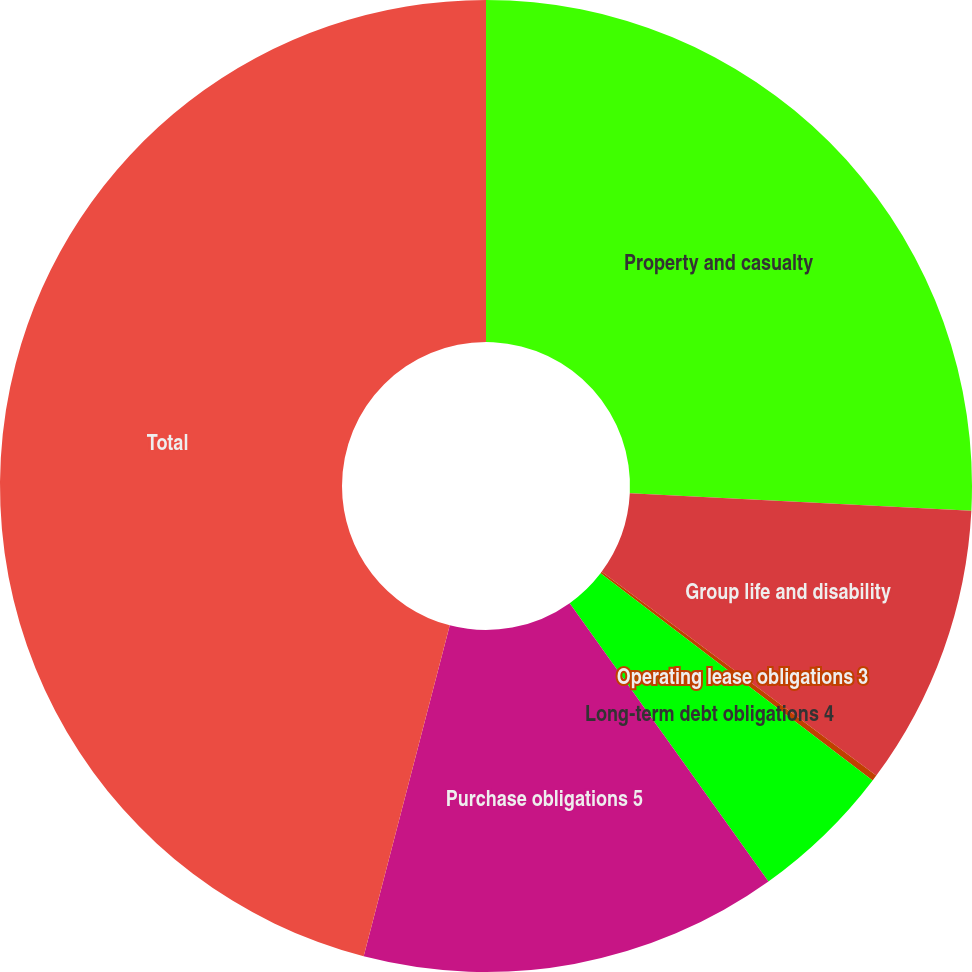Convert chart to OTSL. <chart><loc_0><loc_0><loc_500><loc_500><pie_chart><fcel>Property and casualty<fcel>Group life and disability<fcel>Operating lease obligations 3<fcel>Long-term debt obligations 4<fcel>Purchase obligations 5<fcel>Total<nl><fcel>25.81%<fcel>9.35%<fcel>0.2%<fcel>4.77%<fcel>13.92%<fcel>45.95%<nl></chart> 